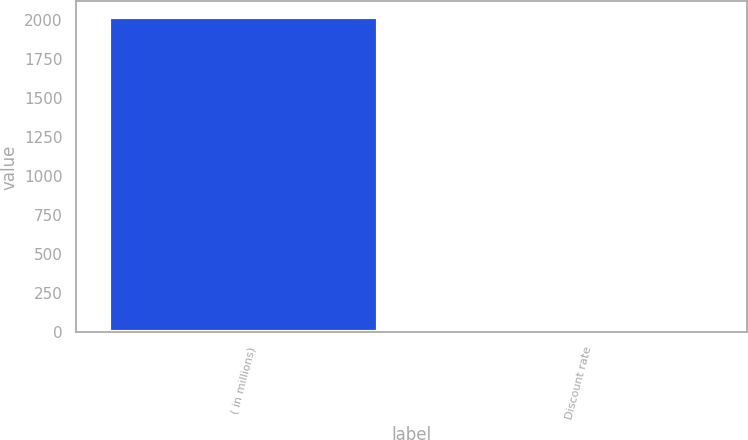Convert chart. <chart><loc_0><loc_0><loc_500><loc_500><bar_chart><fcel>( in millions)<fcel>Discount rate<nl><fcel>2018<fcel>3.63<nl></chart> 